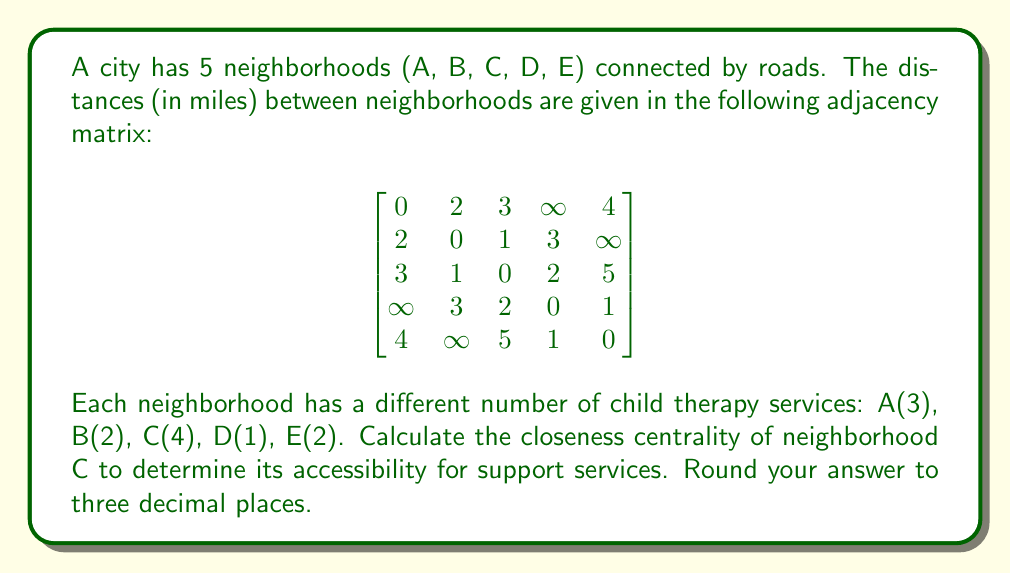Give your solution to this math problem. To solve this problem, we'll follow these steps:

1) Closeness centrality is defined as:

   $C(v) = \frac{n-1}{\sum_{u \neq v} d(v,u)}$

   where $n$ is the number of nodes, and $d(v,u)$ is the shortest distance between nodes v and u.

2) First, we need to find the shortest distances from C to all other neighborhoods. We can read these directly from the matrix for C (third row):

   C to A: 3
   C to B: 1
   C to D: 2
   C to E: 5

3) Sum these distances:

   $\sum_{u \neq v} d(v,u) = 3 + 1 + 2 + 5 = 11$

4) Now we can apply the formula:

   $C(C) = \frac{n-1}{\sum_{u \neq v} d(v,u)} = \frac{5-1}{11} = \frac{4}{11} \approx 0.364$

5) Rounding to three decimal places gives us 0.364.

This value represents the reciprocal of the average distance from C to all other neighborhoods, normalized by the number of other neighborhoods. A higher value indicates better centrality and thus better accessibility to support services across the city.
Answer: 0.364 